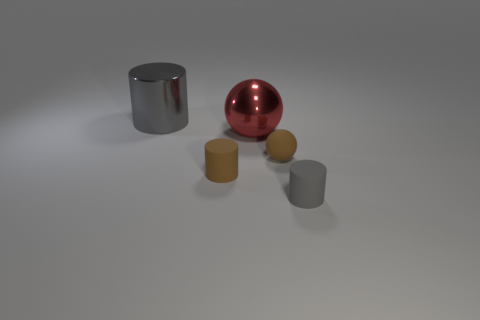What is the material of the big gray cylinder?
Provide a short and direct response. Metal. What is the tiny brown object that is left of the tiny brown matte sphere made of?
Your answer should be compact. Rubber. Is the number of brown cylinders behind the big metal cylinder greater than the number of metallic objects?
Your answer should be very brief. No. There is a gray object in front of the matte cylinder behind the small gray cylinder; is there a tiny brown ball on the left side of it?
Your answer should be compact. Yes. Are there any big metallic objects on the left side of the red object?
Provide a succinct answer. Yes. How many small rubber cylinders are the same color as the large sphere?
Offer a terse response. 0. What size is the gray object that is made of the same material as the large red ball?
Offer a very short reply. Large. There is a rubber cylinder behind the small gray matte cylinder in front of the big object that is behind the red shiny ball; what is its size?
Offer a terse response. Small. There is a gray thing that is in front of the big gray cylinder; how big is it?
Your answer should be compact. Small. How many cyan objects are metal cylinders or large blocks?
Provide a succinct answer. 0. 